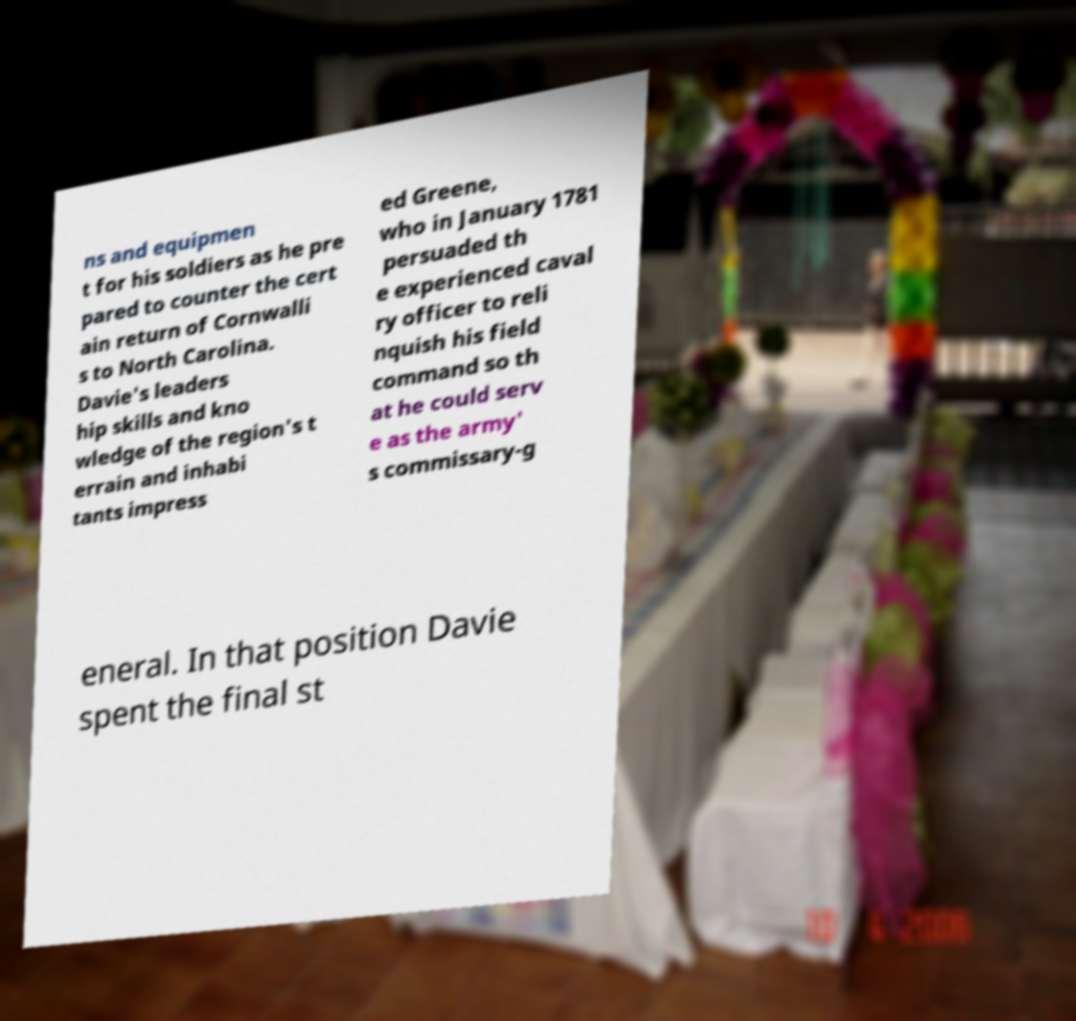Can you accurately transcribe the text from the provided image for me? ns and equipmen t for his soldiers as he pre pared to counter the cert ain return of Cornwalli s to North Carolina. Davie's leaders hip skills and kno wledge of the region's t errain and inhabi tants impress ed Greene, who in January 1781 persuaded th e experienced caval ry officer to reli nquish his field command so th at he could serv e as the army' s commissary-g eneral. In that position Davie spent the final st 